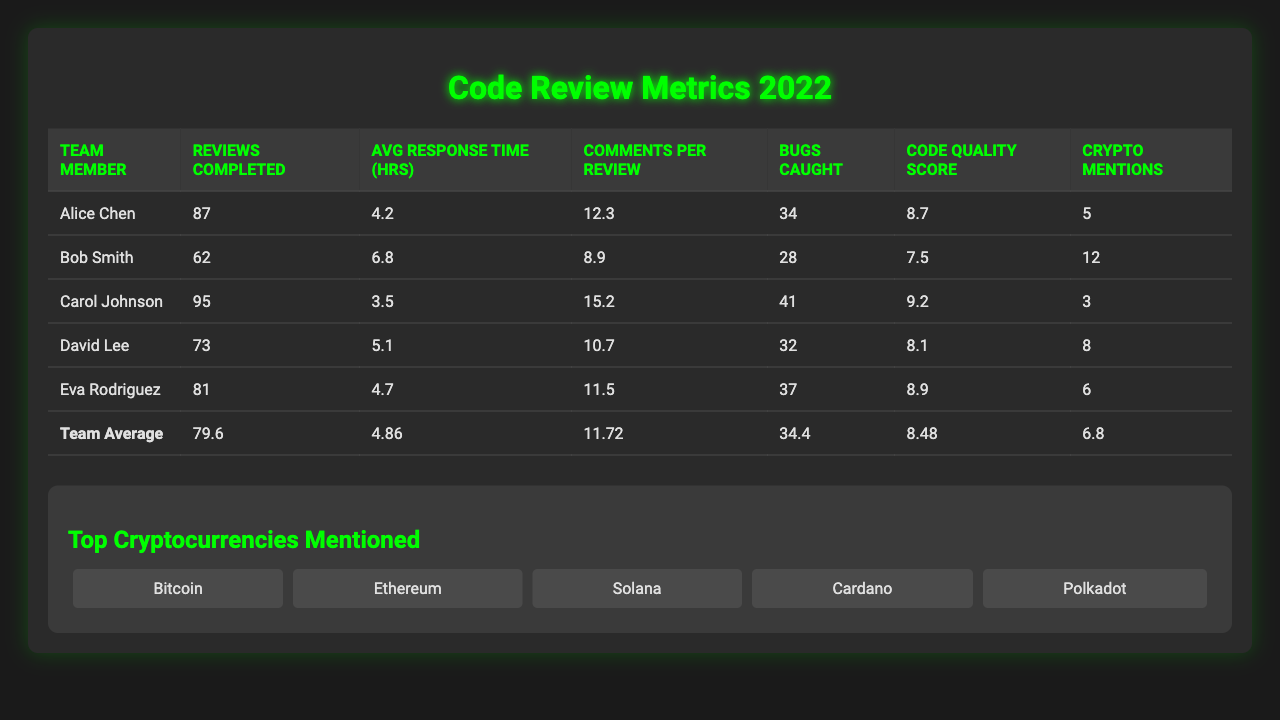What is the average response time for the team? The table lists the average response time for the team as 4.86 hours. This is derived from the average response time provided in the team average metrics section.
Answer: 4.86 hours Who completed the most reviews? Carol Johnson completed the most reviews with a total of 95, which is the highest number among all team members listed.
Answer: Carol Johnson How many bugs did Alice Chen catch? According to the table, Alice Chen caught 34 bugs, as shown in the column labeled "Bugs Caught."
Answer: 34 What is the average number of comments per review by the team members? The table shows the team average for comments per review is 11.72. This value comes from the team average metrics section of the table.
Answer: 11.72 Did Bob Smith have a better average response time than Eva Rodriguez? No, Eva Rodriguez had a better average response time of 4.7 hours compared to Bob Smith's 6.8 hours. This is derived from comparing the average response times listed for each member.
Answer: No What is the total number of cryptocurrency mentions by all team members? To find the total, we sum the cryptocurrency mentions: 5 (Alice) + 12 (Bob) + 3 (Carol) + 8 (David) + 6 (Eva) = 34. This requires summation of the individual counts from the crypto mentions column.
Answer: 34 Which team member caught the most bugs? Carol Johnson caught the most bugs, totaling 41, which is higher than all other members as per the "Bugs Caught" column data.
Answer: Carol Johnson What is the difference in the average response time between the fastest and slowest reviewers? The fastest reviewer is Carol Johnson with 3.5 hours and the slowest is Bob Smith with 6.8 hours. The difference is 6.8 - 3.5 = 3.3 hours. Therefore, we subtract the fastest from the slowest response times.
Answer: 3.3 hours Was the code quality improvement score of Carol Johnson higher than the team average? Yes, Carol Johnson's score is 9.2, which is higher than the team's average of 8.48, indicating that she performed better in this metric compared to the team overall.
Answer: Yes What percentage of the total bugs caught was by Alice Chen? Alice caught 34 bugs out of a total of 34 (Alice) + 28 (Bob) + 41 (Carol) + 32 (David) + 37 (Eva) = 172 bugs total, so (34 / 172) * 100 = 19.77%. We derive the percentage by dividing Alice's count by total bugs and converting it to percentage form.
Answer: 19.77% 